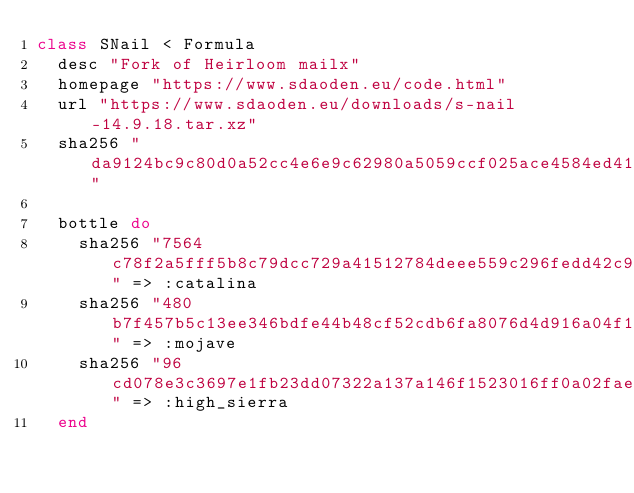Convert code to text. <code><loc_0><loc_0><loc_500><loc_500><_Ruby_>class SNail < Formula
  desc "Fork of Heirloom mailx"
  homepage "https://www.sdaoden.eu/code.html"
  url "https://www.sdaoden.eu/downloads/s-nail-14.9.18.tar.xz"
  sha256 "da9124bc9c80d0a52cc4e6e9c62980a5059ccf025ace4584ed416a61f7dc4cb3"

  bottle do
    sha256 "7564c78f2a5fff5b8c79dcc729a41512784deee559c296fedd42c9c7ba04a05c" => :catalina
    sha256 "480b7f457b5c13ee346bdfe44b48cf52cdb6fa8076d4d916a04f1d61647664e4" => :mojave
    sha256 "96cd078e3c3697e1fb23dd07322a137a146f1523016ff0a02fae89639b058681" => :high_sierra
  end
</code> 